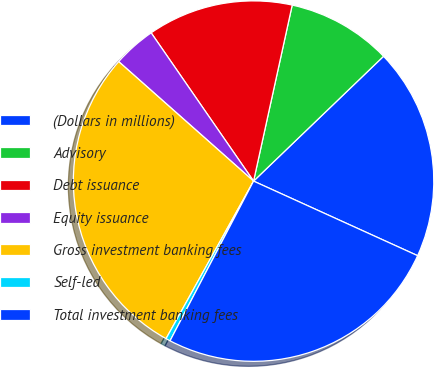Convert chart. <chart><loc_0><loc_0><loc_500><loc_500><pie_chart><fcel>(Dollars in millions)<fcel>Advisory<fcel>Debt issuance<fcel>Equity issuance<fcel>Gross investment banking fees<fcel>Self-led<fcel>Total investment banking fees<nl><fcel>18.97%<fcel>9.38%<fcel>13.06%<fcel>3.84%<fcel>28.47%<fcel>0.4%<fcel>25.88%<nl></chart> 